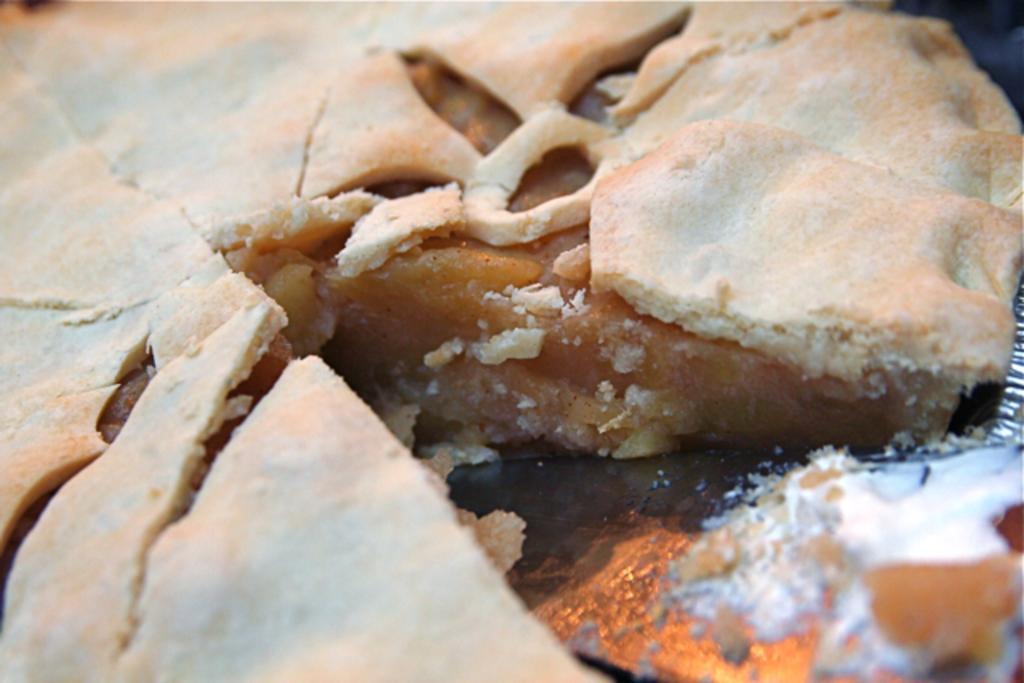Could you give a brief overview of what you see in this image? This is a picture of a food item. 